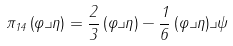Convert formula to latex. <formula><loc_0><loc_0><loc_500><loc_500>\pi _ { 1 4 } \left ( \varphi \lrcorner \eta \right ) = \frac { 2 } { 3 } \left ( \varphi \lrcorner \eta \right ) - \frac { 1 } { 6 } \left ( \varphi \lrcorner \eta \right ) \lrcorner \psi</formula> 